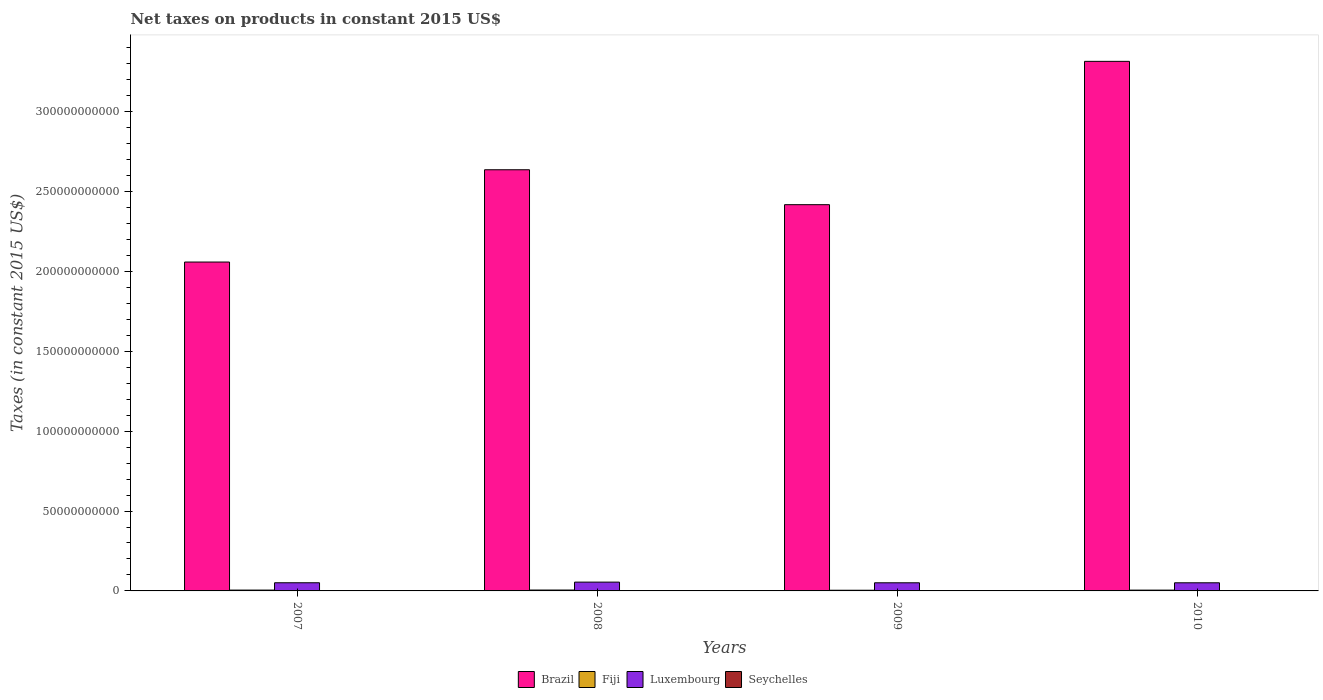Are the number of bars on each tick of the X-axis equal?
Offer a terse response. Yes. How many bars are there on the 2nd tick from the left?
Provide a succinct answer. 4. How many bars are there on the 1st tick from the right?
Your answer should be compact. 4. What is the net taxes on products in Fiji in 2007?
Keep it short and to the point. 5.18e+08. Across all years, what is the maximum net taxes on products in Luxembourg?
Give a very brief answer. 5.51e+09. Across all years, what is the minimum net taxes on products in Luxembourg?
Your answer should be very brief. 5.09e+09. In which year was the net taxes on products in Luxembourg maximum?
Keep it short and to the point. 2008. What is the total net taxes on products in Seychelles in the graph?
Your answer should be compact. 5.67e+08. What is the difference between the net taxes on products in Luxembourg in 2009 and that in 2010?
Provide a succinct answer. 4.51e+06. What is the difference between the net taxes on products in Seychelles in 2008 and the net taxes on products in Brazil in 2010?
Provide a succinct answer. -3.31e+11. What is the average net taxes on products in Luxembourg per year?
Offer a very short reply. 5.20e+09. In the year 2008, what is the difference between the net taxes on products in Fiji and net taxes on products in Seychelles?
Keep it short and to the point. 4.18e+08. What is the ratio of the net taxes on products in Seychelles in 2008 to that in 2010?
Offer a terse response. 0.84. Is the net taxes on products in Brazil in 2008 less than that in 2009?
Keep it short and to the point. No. What is the difference between the highest and the second highest net taxes on products in Fiji?
Keep it short and to the point. 3.66e+07. What is the difference between the highest and the lowest net taxes on products in Seychelles?
Your response must be concise. 3.30e+07. In how many years, is the net taxes on products in Fiji greater than the average net taxes on products in Fiji taken over all years?
Provide a short and direct response. 3. Is the sum of the net taxes on products in Brazil in 2007 and 2008 greater than the maximum net taxes on products in Fiji across all years?
Ensure brevity in your answer.  Yes. Is it the case that in every year, the sum of the net taxes on products in Fiji and net taxes on products in Luxembourg is greater than the sum of net taxes on products in Brazil and net taxes on products in Seychelles?
Your answer should be compact. Yes. What does the 3rd bar from the left in 2008 represents?
Offer a very short reply. Luxembourg. Is it the case that in every year, the sum of the net taxes on products in Seychelles and net taxes on products in Fiji is greater than the net taxes on products in Luxembourg?
Your answer should be compact. No. How many bars are there?
Provide a succinct answer. 16. How many years are there in the graph?
Your answer should be compact. 4. What is the difference between two consecutive major ticks on the Y-axis?
Your response must be concise. 5.00e+1. What is the title of the graph?
Offer a terse response. Net taxes on products in constant 2015 US$. Does "Botswana" appear as one of the legend labels in the graph?
Keep it short and to the point. No. What is the label or title of the Y-axis?
Your answer should be very brief. Taxes (in constant 2015 US$). What is the Taxes (in constant 2015 US$) in Brazil in 2007?
Give a very brief answer. 2.06e+11. What is the Taxes (in constant 2015 US$) in Fiji in 2007?
Provide a short and direct response. 5.18e+08. What is the Taxes (in constant 2015 US$) of Luxembourg in 2007?
Provide a short and direct response. 5.11e+09. What is the Taxes (in constant 2015 US$) of Seychelles in 2007?
Keep it short and to the point. 1.37e+08. What is the Taxes (in constant 2015 US$) in Brazil in 2008?
Provide a short and direct response. 2.64e+11. What is the Taxes (in constant 2015 US$) in Fiji in 2008?
Offer a terse response. 5.55e+08. What is the Taxes (in constant 2015 US$) of Luxembourg in 2008?
Your response must be concise. 5.51e+09. What is the Taxes (in constant 2015 US$) of Seychelles in 2008?
Give a very brief answer. 1.37e+08. What is the Taxes (in constant 2015 US$) of Brazil in 2009?
Your response must be concise. 2.42e+11. What is the Taxes (in constant 2015 US$) of Fiji in 2009?
Give a very brief answer. 4.23e+08. What is the Taxes (in constant 2015 US$) of Luxembourg in 2009?
Your answer should be compact. 5.09e+09. What is the Taxes (in constant 2015 US$) in Seychelles in 2009?
Your answer should be very brief. 1.30e+08. What is the Taxes (in constant 2015 US$) of Brazil in 2010?
Offer a very short reply. 3.31e+11. What is the Taxes (in constant 2015 US$) in Fiji in 2010?
Provide a succinct answer. 5.07e+08. What is the Taxes (in constant 2015 US$) of Luxembourg in 2010?
Make the answer very short. 5.09e+09. What is the Taxes (in constant 2015 US$) of Seychelles in 2010?
Give a very brief answer. 1.63e+08. Across all years, what is the maximum Taxes (in constant 2015 US$) of Brazil?
Offer a very short reply. 3.31e+11. Across all years, what is the maximum Taxes (in constant 2015 US$) in Fiji?
Give a very brief answer. 5.55e+08. Across all years, what is the maximum Taxes (in constant 2015 US$) of Luxembourg?
Ensure brevity in your answer.  5.51e+09. Across all years, what is the maximum Taxes (in constant 2015 US$) in Seychelles?
Your answer should be very brief. 1.63e+08. Across all years, what is the minimum Taxes (in constant 2015 US$) of Brazil?
Offer a terse response. 2.06e+11. Across all years, what is the minimum Taxes (in constant 2015 US$) in Fiji?
Provide a succinct answer. 4.23e+08. Across all years, what is the minimum Taxes (in constant 2015 US$) in Luxembourg?
Provide a succinct answer. 5.09e+09. Across all years, what is the minimum Taxes (in constant 2015 US$) of Seychelles?
Your response must be concise. 1.30e+08. What is the total Taxes (in constant 2015 US$) of Brazil in the graph?
Offer a terse response. 1.04e+12. What is the total Taxes (in constant 2015 US$) in Fiji in the graph?
Provide a succinct answer. 2.00e+09. What is the total Taxes (in constant 2015 US$) of Luxembourg in the graph?
Your answer should be very brief. 2.08e+1. What is the total Taxes (in constant 2015 US$) of Seychelles in the graph?
Your answer should be very brief. 5.67e+08. What is the difference between the Taxes (in constant 2015 US$) in Brazil in 2007 and that in 2008?
Your answer should be compact. -5.78e+1. What is the difference between the Taxes (in constant 2015 US$) of Fiji in 2007 and that in 2008?
Offer a terse response. -3.66e+07. What is the difference between the Taxes (in constant 2015 US$) in Luxembourg in 2007 and that in 2008?
Give a very brief answer. -3.98e+08. What is the difference between the Taxes (in constant 2015 US$) in Seychelles in 2007 and that in 2008?
Your response must be concise. -5.23e+05. What is the difference between the Taxes (in constant 2015 US$) of Brazil in 2007 and that in 2009?
Offer a very short reply. -3.59e+1. What is the difference between the Taxes (in constant 2015 US$) of Fiji in 2007 and that in 2009?
Offer a very short reply. 9.48e+07. What is the difference between the Taxes (in constant 2015 US$) in Luxembourg in 2007 and that in 2009?
Provide a short and direct response. 1.31e+07. What is the difference between the Taxes (in constant 2015 US$) in Seychelles in 2007 and that in 2009?
Provide a succinct answer. 6.78e+06. What is the difference between the Taxes (in constant 2015 US$) in Brazil in 2007 and that in 2010?
Provide a succinct answer. -1.26e+11. What is the difference between the Taxes (in constant 2015 US$) of Fiji in 2007 and that in 2010?
Provide a short and direct response. 1.08e+07. What is the difference between the Taxes (in constant 2015 US$) in Luxembourg in 2007 and that in 2010?
Your answer should be very brief. 1.76e+07. What is the difference between the Taxes (in constant 2015 US$) in Seychelles in 2007 and that in 2010?
Provide a short and direct response. -2.62e+07. What is the difference between the Taxes (in constant 2015 US$) of Brazil in 2008 and that in 2009?
Provide a short and direct response. 2.19e+1. What is the difference between the Taxes (in constant 2015 US$) in Fiji in 2008 and that in 2009?
Ensure brevity in your answer.  1.31e+08. What is the difference between the Taxes (in constant 2015 US$) in Luxembourg in 2008 and that in 2009?
Give a very brief answer. 4.11e+08. What is the difference between the Taxes (in constant 2015 US$) of Seychelles in 2008 and that in 2009?
Provide a short and direct response. 7.30e+06. What is the difference between the Taxes (in constant 2015 US$) in Brazil in 2008 and that in 2010?
Offer a terse response. -6.78e+1. What is the difference between the Taxes (in constant 2015 US$) of Fiji in 2008 and that in 2010?
Your answer should be compact. 4.74e+07. What is the difference between the Taxes (in constant 2015 US$) of Luxembourg in 2008 and that in 2010?
Your response must be concise. 4.16e+08. What is the difference between the Taxes (in constant 2015 US$) of Seychelles in 2008 and that in 2010?
Your answer should be very brief. -2.57e+07. What is the difference between the Taxes (in constant 2015 US$) of Brazil in 2009 and that in 2010?
Make the answer very short. -8.97e+1. What is the difference between the Taxes (in constant 2015 US$) of Fiji in 2009 and that in 2010?
Make the answer very short. -8.40e+07. What is the difference between the Taxes (in constant 2015 US$) of Luxembourg in 2009 and that in 2010?
Ensure brevity in your answer.  4.51e+06. What is the difference between the Taxes (in constant 2015 US$) in Seychelles in 2009 and that in 2010?
Your answer should be compact. -3.30e+07. What is the difference between the Taxes (in constant 2015 US$) in Brazil in 2007 and the Taxes (in constant 2015 US$) in Fiji in 2008?
Ensure brevity in your answer.  2.05e+11. What is the difference between the Taxes (in constant 2015 US$) of Brazil in 2007 and the Taxes (in constant 2015 US$) of Luxembourg in 2008?
Offer a very short reply. 2.00e+11. What is the difference between the Taxes (in constant 2015 US$) in Brazil in 2007 and the Taxes (in constant 2015 US$) in Seychelles in 2008?
Keep it short and to the point. 2.06e+11. What is the difference between the Taxes (in constant 2015 US$) of Fiji in 2007 and the Taxes (in constant 2015 US$) of Luxembourg in 2008?
Provide a succinct answer. -4.99e+09. What is the difference between the Taxes (in constant 2015 US$) of Fiji in 2007 and the Taxes (in constant 2015 US$) of Seychelles in 2008?
Ensure brevity in your answer.  3.81e+08. What is the difference between the Taxes (in constant 2015 US$) in Luxembourg in 2007 and the Taxes (in constant 2015 US$) in Seychelles in 2008?
Your answer should be very brief. 4.97e+09. What is the difference between the Taxes (in constant 2015 US$) in Brazil in 2007 and the Taxes (in constant 2015 US$) in Fiji in 2009?
Provide a short and direct response. 2.05e+11. What is the difference between the Taxes (in constant 2015 US$) of Brazil in 2007 and the Taxes (in constant 2015 US$) of Luxembourg in 2009?
Give a very brief answer. 2.01e+11. What is the difference between the Taxes (in constant 2015 US$) of Brazil in 2007 and the Taxes (in constant 2015 US$) of Seychelles in 2009?
Keep it short and to the point. 2.06e+11. What is the difference between the Taxes (in constant 2015 US$) of Fiji in 2007 and the Taxes (in constant 2015 US$) of Luxembourg in 2009?
Your response must be concise. -4.58e+09. What is the difference between the Taxes (in constant 2015 US$) in Fiji in 2007 and the Taxes (in constant 2015 US$) in Seychelles in 2009?
Keep it short and to the point. 3.88e+08. What is the difference between the Taxes (in constant 2015 US$) of Luxembourg in 2007 and the Taxes (in constant 2015 US$) of Seychelles in 2009?
Ensure brevity in your answer.  4.98e+09. What is the difference between the Taxes (in constant 2015 US$) in Brazil in 2007 and the Taxes (in constant 2015 US$) in Fiji in 2010?
Provide a succinct answer. 2.05e+11. What is the difference between the Taxes (in constant 2015 US$) in Brazil in 2007 and the Taxes (in constant 2015 US$) in Luxembourg in 2010?
Give a very brief answer. 2.01e+11. What is the difference between the Taxes (in constant 2015 US$) of Brazil in 2007 and the Taxes (in constant 2015 US$) of Seychelles in 2010?
Offer a terse response. 2.06e+11. What is the difference between the Taxes (in constant 2015 US$) of Fiji in 2007 and the Taxes (in constant 2015 US$) of Luxembourg in 2010?
Offer a very short reply. -4.57e+09. What is the difference between the Taxes (in constant 2015 US$) in Fiji in 2007 and the Taxes (in constant 2015 US$) in Seychelles in 2010?
Your answer should be compact. 3.55e+08. What is the difference between the Taxes (in constant 2015 US$) of Luxembourg in 2007 and the Taxes (in constant 2015 US$) of Seychelles in 2010?
Offer a terse response. 4.94e+09. What is the difference between the Taxes (in constant 2015 US$) of Brazil in 2008 and the Taxes (in constant 2015 US$) of Fiji in 2009?
Ensure brevity in your answer.  2.63e+11. What is the difference between the Taxes (in constant 2015 US$) of Brazil in 2008 and the Taxes (in constant 2015 US$) of Luxembourg in 2009?
Provide a short and direct response. 2.58e+11. What is the difference between the Taxes (in constant 2015 US$) in Brazil in 2008 and the Taxes (in constant 2015 US$) in Seychelles in 2009?
Give a very brief answer. 2.63e+11. What is the difference between the Taxes (in constant 2015 US$) in Fiji in 2008 and the Taxes (in constant 2015 US$) in Luxembourg in 2009?
Keep it short and to the point. -4.54e+09. What is the difference between the Taxes (in constant 2015 US$) in Fiji in 2008 and the Taxes (in constant 2015 US$) in Seychelles in 2009?
Your answer should be very brief. 4.25e+08. What is the difference between the Taxes (in constant 2015 US$) in Luxembourg in 2008 and the Taxes (in constant 2015 US$) in Seychelles in 2009?
Your answer should be very brief. 5.38e+09. What is the difference between the Taxes (in constant 2015 US$) in Brazil in 2008 and the Taxes (in constant 2015 US$) in Fiji in 2010?
Keep it short and to the point. 2.63e+11. What is the difference between the Taxes (in constant 2015 US$) in Brazil in 2008 and the Taxes (in constant 2015 US$) in Luxembourg in 2010?
Your response must be concise. 2.58e+11. What is the difference between the Taxes (in constant 2015 US$) in Brazil in 2008 and the Taxes (in constant 2015 US$) in Seychelles in 2010?
Your answer should be compact. 2.63e+11. What is the difference between the Taxes (in constant 2015 US$) of Fiji in 2008 and the Taxes (in constant 2015 US$) of Luxembourg in 2010?
Ensure brevity in your answer.  -4.53e+09. What is the difference between the Taxes (in constant 2015 US$) of Fiji in 2008 and the Taxes (in constant 2015 US$) of Seychelles in 2010?
Offer a terse response. 3.92e+08. What is the difference between the Taxes (in constant 2015 US$) in Luxembourg in 2008 and the Taxes (in constant 2015 US$) in Seychelles in 2010?
Make the answer very short. 5.34e+09. What is the difference between the Taxes (in constant 2015 US$) in Brazil in 2009 and the Taxes (in constant 2015 US$) in Fiji in 2010?
Offer a very short reply. 2.41e+11. What is the difference between the Taxes (in constant 2015 US$) in Brazil in 2009 and the Taxes (in constant 2015 US$) in Luxembourg in 2010?
Offer a very short reply. 2.37e+11. What is the difference between the Taxes (in constant 2015 US$) in Brazil in 2009 and the Taxes (in constant 2015 US$) in Seychelles in 2010?
Offer a terse response. 2.42e+11. What is the difference between the Taxes (in constant 2015 US$) in Fiji in 2009 and the Taxes (in constant 2015 US$) in Luxembourg in 2010?
Your response must be concise. -4.67e+09. What is the difference between the Taxes (in constant 2015 US$) in Fiji in 2009 and the Taxes (in constant 2015 US$) in Seychelles in 2010?
Provide a succinct answer. 2.61e+08. What is the difference between the Taxes (in constant 2015 US$) of Luxembourg in 2009 and the Taxes (in constant 2015 US$) of Seychelles in 2010?
Make the answer very short. 4.93e+09. What is the average Taxes (in constant 2015 US$) of Brazil per year?
Offer a very short reply. 2.61e+11. What is the average Taxes (in constant 2015 US$) in Fiji per year?
Offer a terse response. 5.01e+08. What is the average Taxes (in constant 2015 US$) of Luxembourg per year?
Your response must be concise. 5.20e+09. What is the average Taxes (in constant 2015 US$) in Seychelles per year?
Offer a very short reply. 1.42e+08. In the year 2007, what is the difference between the Taxes (in constant 2015 US$) in Brazil and Taxes (in constant 2015 US$) in Fiji?
Offer a very short reply. 2.05e+11. In the year 2007, what is the difference between the Taxes (in constant 2015 US$) in Brazil and Taxes (in constant 2015 US$) in Luxembourg?
Offer a very short reply. 2.01e+11. In the year 2007, what is the difference between the Taxes (in constant 2015 US$) in Brazil and Taxes (in constant 2015 US$) in Seychelles?
Provide a short and direct response. 2.06e+11. In the year 2007, what is the difference between the Taxes (in constant 2015 US$) in Fiji and Taxes (in constant 2015 US$) in Luxembourg?
Offer a very short reply. -4.59e+09. In the year 2007, what is the difference between the Taxes (in constant 2015 US$) in Fiji and Taxes (in constant 2015 US$) in Seychelles?
Keep it short and to the point. 3.82e+08. In the year 2007, what is the difference between the Taxes (in constant 2015 US$) in Luxembourg and Taxes (in constant 2015 US$) in Seychelles?
Make the answer very short. 4.97e+09. In the year 2008, what is the difference between the Taxes (in constant 2015 US$) of Brazil and Taxes (in constant 2015 US$) of Fiji?
Ensure brevity in your answer.  2.63e+11. In the year 2008, what is the difference between the Taxes (in constant 2015 US$) in Brazil and Taxes (in constant 2015 US$) in Luxembourg?
Your response must be concise. 2.58e+11. In the year 2008, what is the difference between the Taxes (in constant 2015 US$) of Brazil and Taxes (in constant 2015 US$) of Seychelles?
Make the answer very short. 2.63e+11. In the year 2008, what is the difference between the Taxes (in constant 2015 US$) of Fiji and Taxes (in constant 2015 US$) of Luxembourg?
Your answer should be compact. -4.95e+09. In the year 2008, what is the difference between the Taxes (in constant 2015 US$) of Fiji and Taxes (in constant 2015 US$) of Seychelles?
Provide a short and direct response. 4.18e+08. In the year 2008, what is the difference between the Taxes (in constant 2015 US$) of Luxembourg and Taxes (in constant 2015 US$) of Seychelles?
Your answer should be compact. 5.37e+09. In the year 2009, what is the difference between the Taxes (in constant 2015 US$) in Brazil and Taxes (in constant 2015 US$) in Fiji?
Your response must be concise. 2.41e+11. In the year 2009, what is the difference between the Taxes (in constant 2015 US$) of Brazil and Taxes (in constant 2015 US$) of Luxembourg?
Ensure brevity in your answer.  2.37e+11. In the year 2009, what is the difference between the Taxes (in constant 2015 US$) in Brazil and Taxes (in constant 2015 US$) in Seychelles?
Ensure brevity in your answer.  2.42e+11. In the year 2009, what is the difference between the Taxes (in constant 2015 US$) in Fiji and Taxes (in constant 2015 US$) in Luxembourg?
Keep it short and to the point. -4.67e+09. In the year 2009, what is the difference between the Taxes (in constant 2015 US$) in Fiji and Taxes (in constant 2015 US$) in Seychelles?
Offer a very short reply. 2.94e+08. In the year 2009, what is the difference between the Taxes (in constant 2015 US$) of Luxembourg and Taxes (in constant 2015 US$) of Seychelles?
Keep it short and to the point. 4.96e+09. In the year 2010, what is the difference between the Taxes (in constant 2015 US$) in Brazil and Taxes (in constant 2015 US$) in Fiji?
Your answer should be very brief. 3.31e+11. In the year 2010, what is the difference between the Taxes (in constant 2015 US$) in Brazil and Taxes (in constant 2015 US$) in Luxembourg?
Give a very brief answer. 3.26e+11. In the year 2010, what is the difference between the Taxes (in constant 2015 US$) in Brazil and Taxes (in constant 2015 US$) in Seychelles?
Offer a terse response. 3.31e+11. In the year 2010, what is the difference between the Taxes (in constant 2015 US$) of Fiji and Taxes (in constant 2015 US$) of Luxembourg?
Your response must be concise. -4.58e+09. In the year 2010, what is the difference between the Taxes (in constant 2015 US$) of Fiji and Taxes (in constant 2015 US$) of Seychelles?
Give a very brief answer. 3.45e+08. In the year 2010, what is the difference between the Taxes (in constant 2015 US$) of Luxembourg and Taxes (in constant 2015 US$) of Seychelles?
Keep it short and to the point. 4.93e+09. What is the ratio of the Taxes (in constant 2015 US$) in Brazil in 2007 to that in 2008?
Your answer should be very brief. 0.78. What is the ratio of the Taxes (in constant 2015 US$) in Fiji in 2007 to that in 2008?
Your response must be concise. 0.93. What is the ratio of the Taxes (in constant 2015 US$) in Luxembourg in 2007 to that in 2008?
Provide a succinct answer. 0.93. What is the ratio of the Taxes (in constant 2015 US$) in Brazil in 2007 to that in 2009?
Ensure brevity in your answer.  0.85. What is the ratio of the Taxes (in constant 2015 US$) in Fiji in 2007 to that in 2009?
Your answer should be very brief. 1.22. What is the ratio of the Taxes (in constant 2015 US$) in Luxembourg in 2007 to that in 2009?
Offer a terse response. 1. What is the ratio of the Taxes (in constant 2015 US$) of Seychelles in 2007 to that in 2009?
Give a very brief answer. 1.05. What is the ratio of the Taxes (in constant 2015 US$) in Brazil in 2007 to that in 2010?
Your answer should be very brief. 0.62. What is the ratio of the Taxes (in constant 2015 US$) of Fiji in 2007 to that in 2010?
Your response must be concise. 1.02. What is the ratio of the Taxes (in constant 2015 US$) of Luxembourg in 2007 to that in 2010?
Offer a very short reply. 1. What is the ratio of the Taxes (in constant 2015 US$) of Seychelles in 2007 to that in 2010?
Offer a very short reply. 0.84. What is the ratio of the Taxes (in constant 2015 US$) in Brazil in 2008 to that in 2009?
Keep it short and to the point. 1.09. What is the ratio of the Taxes (in constant 2015 US$) in Fiji in 2008 to that in 2009?
Provide a short and direct response. 1.31. What is the ratio of the Taxes (in constant 2015 US$) in Luxembourg in 2008 to that in 2009?
Provide a short and direct response. 1.08. What is the ratio of the Taxes (in constant 2015 US$) in Seychelles in 2008 to that in 2009?
Keep it short and to the point. 1.06. What is the ratio of the Taxes (in constant 2015 US$) in Brazil in 2008 to that in 2010?
Ensure brevity in your answer.  0.8. What is the ratio of the Taxes (in constant 2015 US$) in Fiji in 2008 to that in 2010?
Your answer should be very brief. 1.09. What is the ratio of the Taxes (in constant 2015 US$) in Luxembourg in 2008 to that in 2010?
Offer a terse response. 1.08. What is the ratio of the Taxes (in constant 2015 US$) in Seychelles in 2008 to that in 2010?
Give a very brief answer. 0.84. What is the ratio of the Taxes (in constant 2015 US$) of Brazil in 2009 to that in 2010?
Make the answer very short. 0.73. What is the ratio of the Taxes (in constant 2015 US$) of Fiji in 2009 to that in 2010?
Ensure brevity in your answer.  0.83. What is the ratio of the Taxes (in constant 2015 US$) in Luxembourg in 2009 to that in 2010?
Give a very brief answer. 1. What is the ratio of the Taxes (in constant 2015 US$) of Seychelles in 2009 to that in 2010?
Offer a terse response. 0.8. What is the difference between the highest and the second highest Taxes (in constant 2015 US$) in Brazil?
Provide a succinct answer. 6.78e+1. What is the difference between the highest and the second highest Taxes (in constant 2015 US$) of Fiji?
Your answer should be very brief. 3.66e+07. What is the difference between the highest and the second highest Taxes (in constant 2015 US$) in Luxembourg?
Your answer should be compact. 3.98e+08. What is the difference between the highest and the second highest Taxes (in constant 2015 US$) of Seychelles?
Offer a terse response. 2.57e+07. What is the difference between the highest and the lowest Taxes (in constant 2015 US$) in Brazil?
Provide a short and direct response. 1.26e+11. What is the difference between the highest and the lowest Taxes (in constant 2015 US$) of Fiji?
Keep it short and to the point. 1.31e+08. What is the difference between the highest and the lowest Taxes (in constant 2015 US$) of Luxembourg?
Your response must be concise. 4.16e+08. What is the difference between the highest and the lowest Taxes (in constant 2015 US$) of Seychelles?
Ensure brevity in your answer.  3.30e+07. 